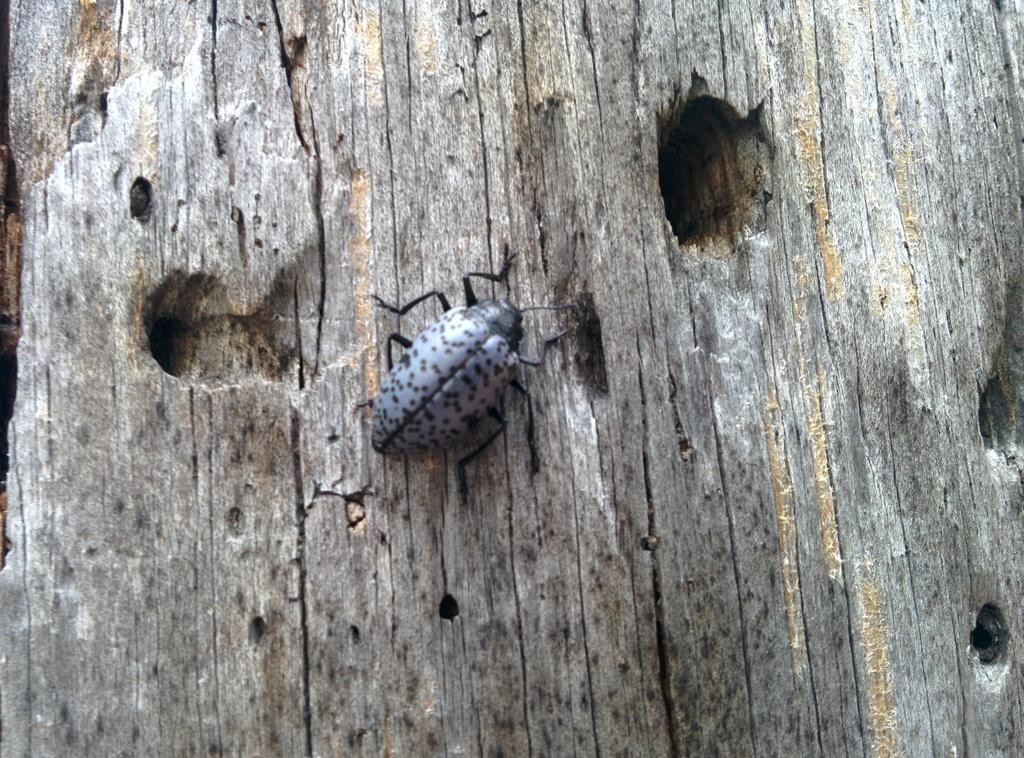What type of creature is present in the image? There is an insect in the image. Where is the insect located? The insect is on a tree. Can you describe the background of the image? There is a tree in the background of the image. How many sisters does the insect have in the image? There are no sisters mentioned or depicted in the image, as it features an insect on a tree. 